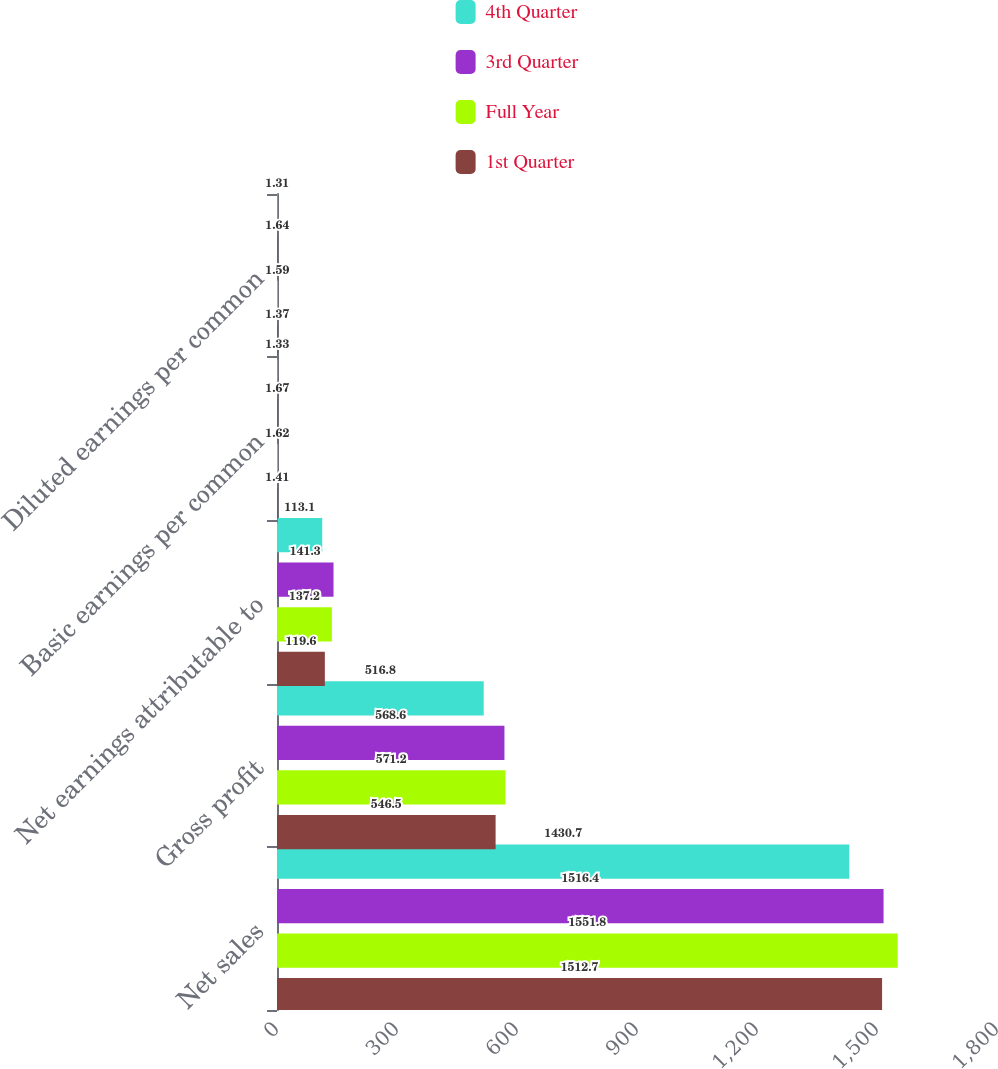Convert chart. <chart><loc_0><loc_0><loc_500><loc_500><stacked_bar_chart><ecel><fcel>Net sales<fcel>Gross profit<fcel>Net earnings attributable to<fcel>Basic earnings per common<fcel>Diluted earnings per common<nl><fcel>4th Quarter<fcel>1430.7<fcel>516.8<fcel>113.1<fcel>1.33<fcel>1.31<nl><fcel>3rd Quarter<fcel>1516.4<fcel>568.6<fcel>141.3<fcel>1.67<fcel>1.64<nl><fcel>Full Year<fcel>1551.8<fcel>571.2<fcel>137.2<fcel>1.62<fcel>1.59<nl><fcel>1st Quarter<fcel>1512.7<fcel>546.5<fcel>119.6<fcel>1.41<fcel>1.37<nl></chart> 